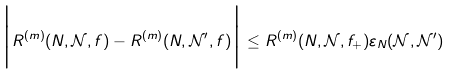<formula> <loc_0><loc_0><loc_500><loc_500>\Big { | } R ^ { ( m ) } ( N , \mathcal { N } , f ) - R ^ { ( m ) } ( N , \mathcal { N } ^ { \prime } , f ) \Big { | } \leq R ^ { ( m ) } ( N , \mathcal { N } , f _ { + } ) \varepsilon _ { N } ( \mathcal { N } , \mathcal { N } ^ { \prime } )</formula> 